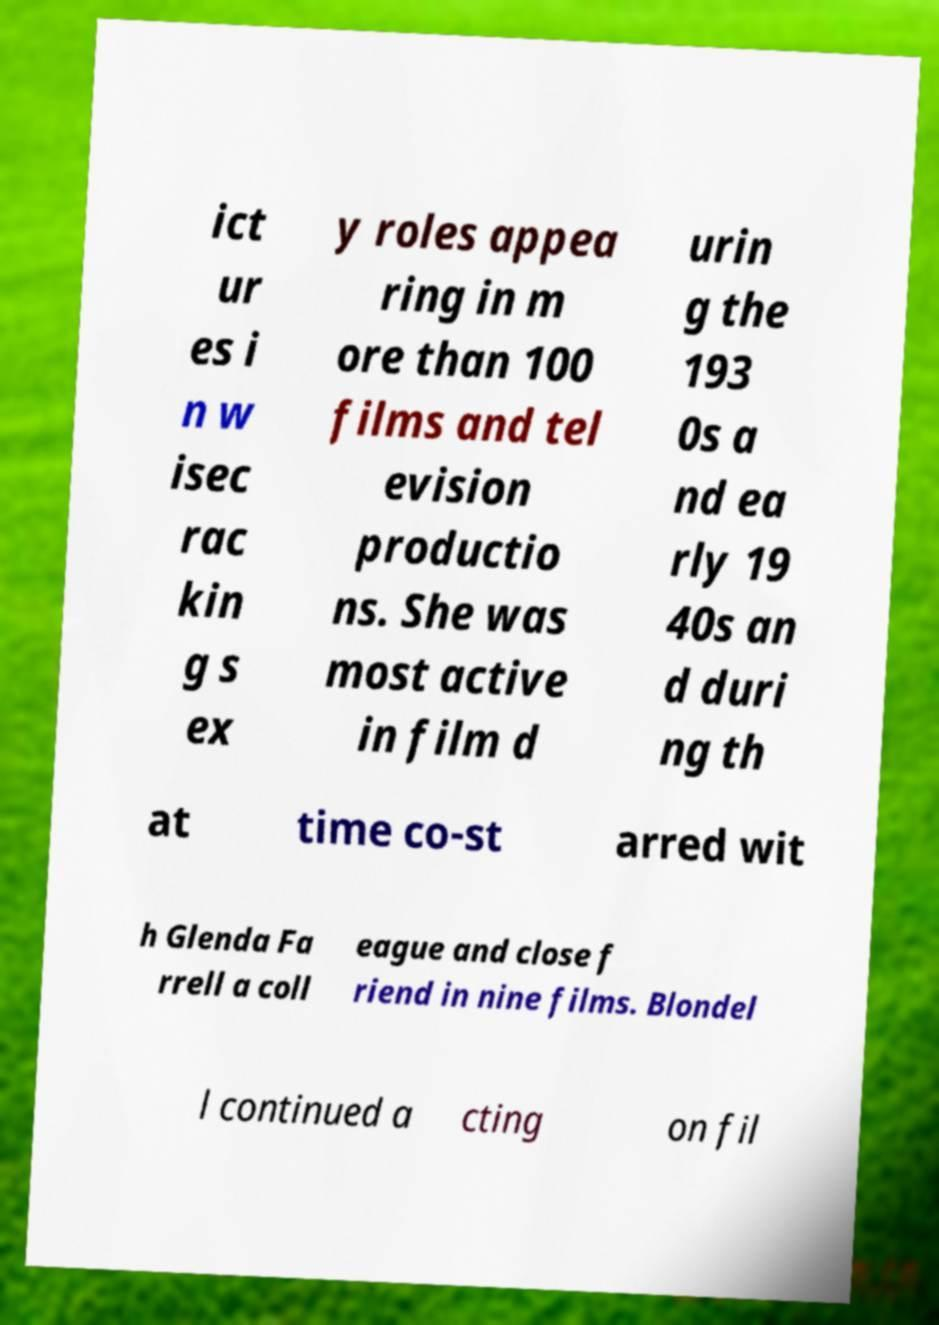Can you read and provide the text displayed in the image?This photo seems to have some interesting text. Can you extract and type it out for me? ict ur es i n w isec rac kin g s ex y roles appea ring in m ore than 100 films and tel evision productio ns. She was most active in film d urin g the 193 0s a nd ea rly 19 40s an d duri ng th at time co-st arred wit h Glenda Fa rrell a coll eague and close f riend in nine films. Blondel l continued a cting on fil 